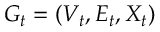<formula> <loc_0><loc_0><loc_500><loc_500>G _ { t } = ( V _ { t } , E _ { t } , X _ { t } )</formula> 